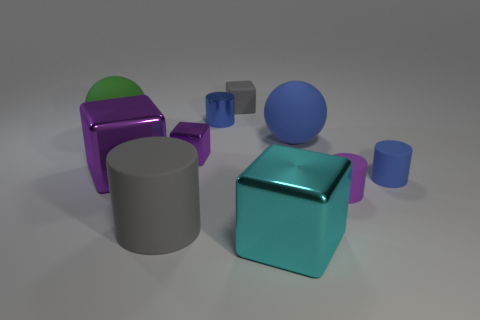There is a large thing that is the same color as the shiny cylinder; what is its material?
Offer a very short reply. Rubber. The tiny shiny object in front of the large blue ball is what color?
Give a very brief answer. Purple. Do the sphere that is left of the gray matte cylinder and the purple matte cylinder have the same size?
Offer a very short reply. No. There is a matte block that is the same color as the big cylinder; what is its size?
Your answer should be very brief. Small. Are there any gray cylinders of the same size as the green thing?
Provide a short and direct response. Yes. There is a large matte sphere right of the big cyan metallic block; is it the same color as the cylinder behind the small blue matte cylinder?
Your answer should be compact. Yes. Are there any small rubber cylinders of the same color as the small metal block?
Provide a succinct answer. Yes. How many other things are the same shape as the small blue shiny thing?
Your answer should be very brief. 3. What is the shape of the gray matte object in front of the tiny purple matte cylinder?
Provide a succinct answer. Cylinder. There is a large cyan shiny thing; is it the same shape as the gray object that is on the right side of the gray matte cylinder?
Make the answer very short. Yes. 